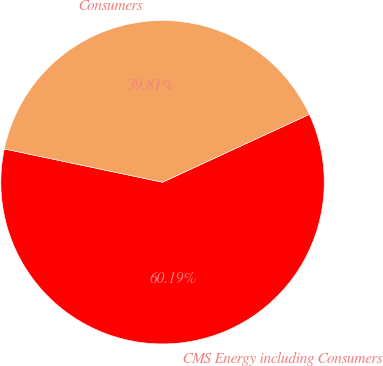Convert chart to OTSL. <chart><loc_0><loc_0><loc_500><loc_500><pie_chart><fcel>CMS Energy including Consumers<fcel>Consumers<nl><fcel>60.19%<fcel>39.81%<nl></chart> 